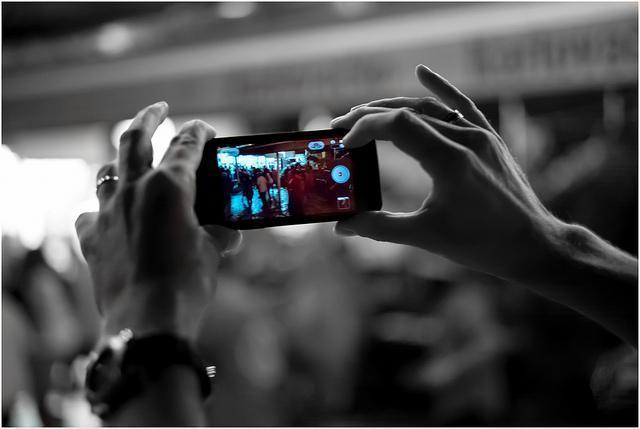How many black umbrellas are in the image?
Give a very brief answer. 0. 